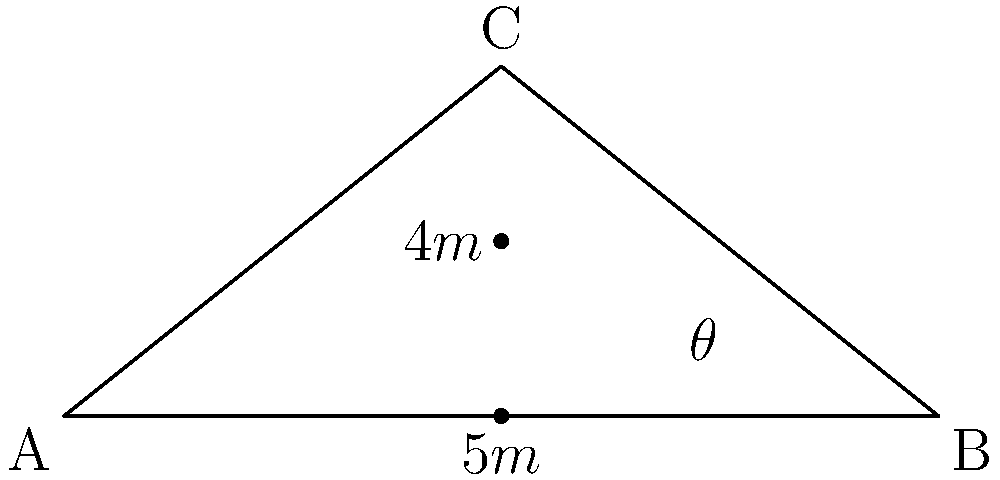As a horticulturist specializing in organic pest control, you're designing a greenhouse with an optimal roof angle to maximize natural pest deterrence. The greenhouse has a width of 10 meters, and the roof peak is 4 meters above the midpoint of the base. What is the angle of inclination ($\theta$) of the roof that provides the best environment for natural pest control? To find the angle of inclination ($\theta$), we can use trigonometry in the right triangle formed by half of the greenhouse roof:

1. Identify the triangle: We have a right triangle with the following measurements:
   - Base (half of the greenhouse width): 5 meters
   - Height (roof peak height): 4 meters
   - Hypotenuse: the roof segment

2. Use the tangent function to find the angle:
   $\tan(\theta) = \frac{\text{opposite}}{\text{adjacent}} = \frac{\text{height}}{\text{half-width}} = \frac{4}{5}$

3. To find $\theta$, we need to use the inverse tangent (arctangent) function:
   $\theta = \arctan(\frac{4}{5})$

4. Calculate the result:
   $\theta \approx 38.66°$

This angle of approximately 38.66° provides an optimal environment for natural pest control by:
- Allowing proper air circulation to reduce humidity and discourage pests
- Maximizing sunlight exposure for plant health and natural pest resistance
- Creating a suitable slope for rainwater runoff, preventing water accumulation that could attract pests
Answer: $38.66°$ 